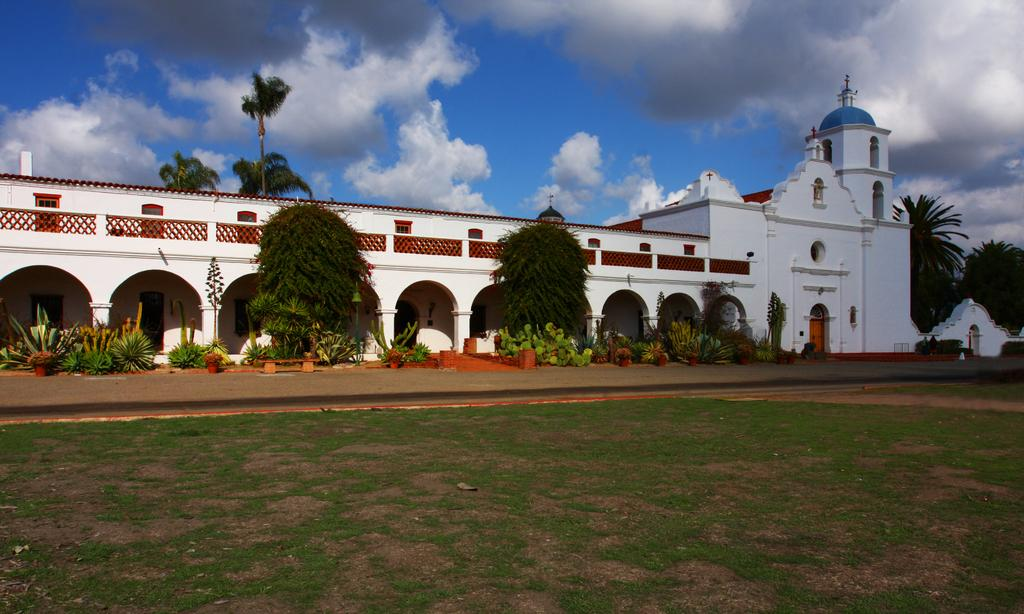What type of structure is present in the image? There is a building in the image. What other natural elements can be seen in the image? There are plants, trees, and grass visible in the image. Is there a designated walking area in the image? Yes, there is a path visible in the image. What is visible in the background of the image? The sky is visible in the background of the image. How would you describe the weather based on the sky in the image? The sky appears to be cloudy in the image. What type of ornament is hanging from the trees in the image? There are no ornaments hanging from the trees in the image; only plants, trees, and grass are present. What is the material of the brass sculpture in the image? There is no brass sculpture present in the image. 